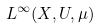Convert formula to latex. <formula><loc_0><loc_0><loc_500><loc_500>L ^ { \infty } ( X , U , \mu )</formula> 